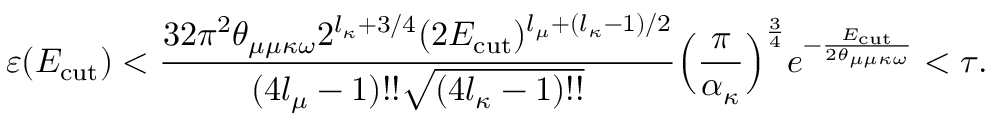<formula> <loc_0><loc_0><loc_500><loc_500>\varepsilon ( E _ { c u t } ) < \frac { 3 2 \pi ^ { 2 } \theta _ { \mu \mu \kappa \omega } 2 ^ { l _ { \kappa } + 3 / 4 } ( 2 E _ { c u t } ) ^ { l _ { \mu } + ( l _ { \kappa } - 1 ) / 2 } } { ( 4 l _ { \mu } - 1 ) ! ! \sqrt { ( 4 l _ { \kappa } - 1 ) ! ! } } \left ( \frac { \pi } { \alpha _ { \kappa } } \right ) ^ { \frac { 3 } { 4 } } e ^ { - \frac { E _ { c u t } } { 2 \theta _ { \mu \mu \kappa \omega } } } < \tau .</formula> 